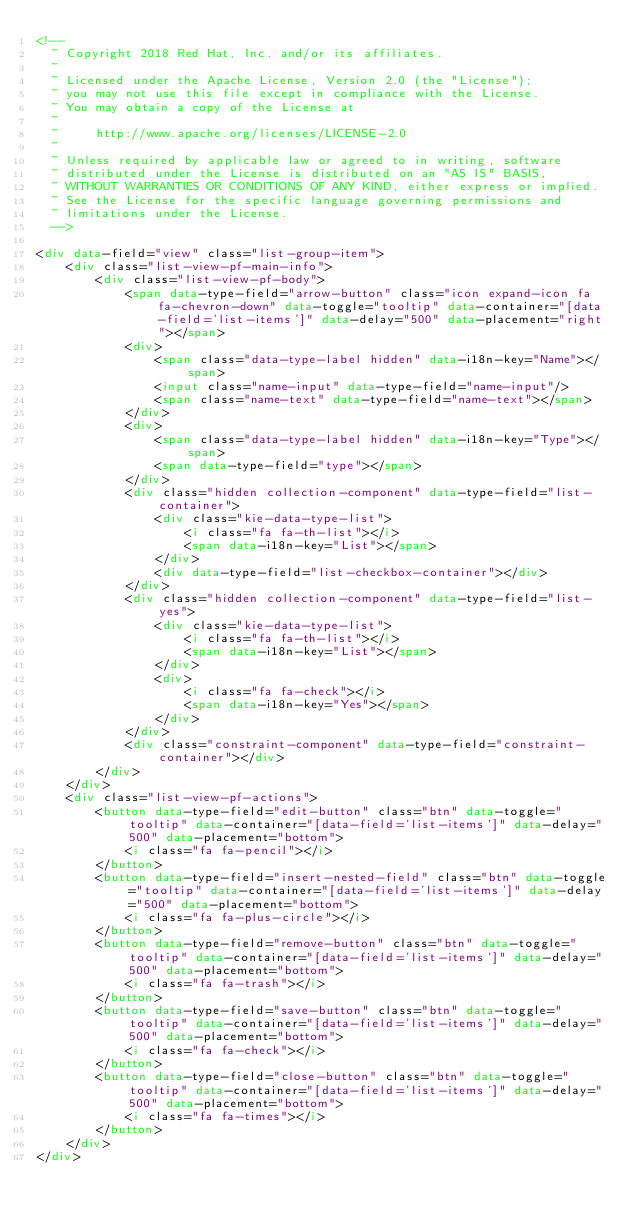<code> <loc_0><loc_0><loc_500><loc_500><_HTML_><!--
  ~ Copyright 2018 Red Hat, Inc. and/or its affiliates.
  ~
  ~ Licensed under the Apache License, Version 2.0 (the "License");
  ~ you may not use this file except in compliance with the License.
  ~ You may obtain a copy of the License at
  ~
  ~     http://www.apache.org/licenses/LICENSE-2.0
  ~
  ~ Unless required by applicable law or agreed to in writing, software
  ~ distributed under the License is distributed on an "AS IS" BASIS,
  ~ WITHOUT WARRANTIES OR CONDITIONS OF ANY KIND, either express or implied.
  ~ See the License for the specific language governing permissions and
  ~ limitations under the License.
  -->

<div data-field="view" class="list-group-item">
    <div class="list-view-pf-main-info">
        <div class="list-view-pf-body">
            <span data-type-field="arrow-button" class="icon expand-icon fa fa-chevron-down" data-toggle="tooltip" data-container="[data-field='list-items']" data-delay="500" data-placement="right"></span>
            <div>
                <span class="data-type-label hidden" data-i18n-key="Name"></span>
                <input class="name-input" data-type-field="name-input"/>
                <span class="name-text" data-type-field="name-text"></span>
            </div>
            <div>
                <span class="data-type-label hidden" data-i18n-key="Type"></span>
                <span data-type-field="type"></span>
            </div>
            <div class="hidden collection-component" data-type-field="list-container">
                <div class="kie-data-type-list">
                    <i class="fa fa-th-list"></i>
                    <span data-i18n-key="List"></span>
                </div>
                <div data-type-field="list-checkbox-container"></div>
            </div>
            <div class="hidden collection-component" data-type-field="list-yes">
                <div class="kie-data-type-list">
                    <i class="fa fa-th-list"></i>
                    <span data-i18n-key="List"></span>
                </div>
                <div>
                    <i class="fa fa-check"></i>
                    <span data-i18n-key="Yes"></span>
                </div>
            </div>
            <div class="constraint-component" data-type-field="constraint-container"></div>
        </div>
    </div>
    <div class="list-view-pf-actions">
        <button data-type-field="edit-button" class="btn" data-toggle="tooltip" data-container="[data-field='list-items']" data-delay="500" data-placement="bottom">
            <i class="fa fa-pencil"></i>
        </button>
        <button data-type-field="insert-nested-field" class="btn" data-toggle="tooltip" data-container="[data-field='list-items']" data-delay="500" data-placement="bottom">
            <i class="fa fa-plus-circle"></i>
        </button>
        <button data-type-field="remove-button" class="btn" data-toggle="tooltip" data-container="[data-field='list-items']" data-delay="500" data-placement="bottom">
            <i class="fa fa-trash"></i>
        </button>
        <button data-type-field="save-button" class="btn" data-toggle="tooltip" data-container="[data-field='list-items']" data-delay="500" data-placement="bottom">
            <i class="fa fa-check"></i>
        </button>
        <button data-type-field="close-button" class="btn" data-toggle="tooltip" data-container="[data-field='list-items']" data-delay="500" data-placement="bottom">
            <i class="fa fa-times"></i>
        </button>
    </div>
</div>
</code> 